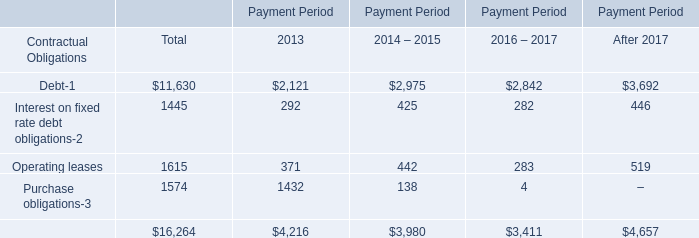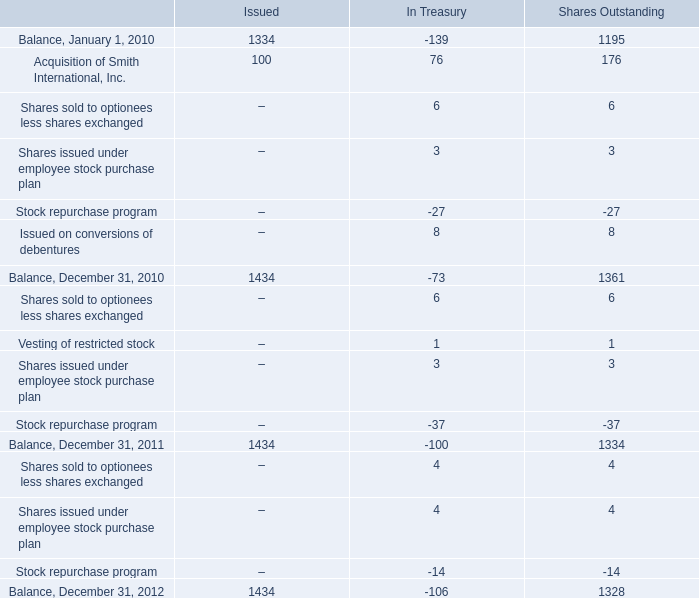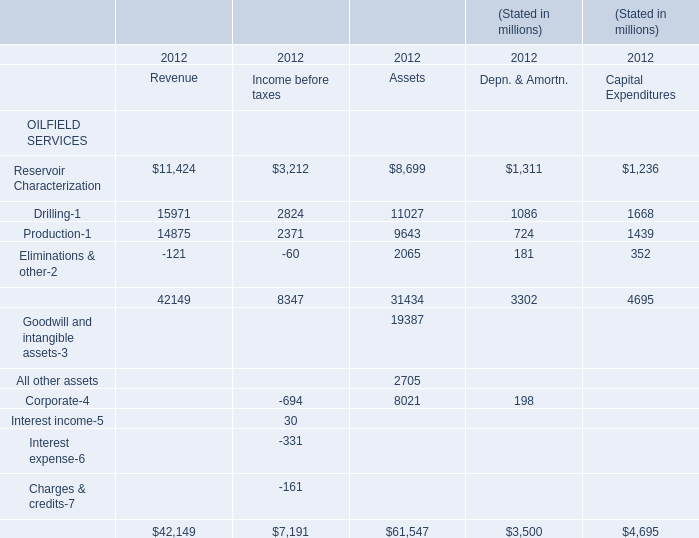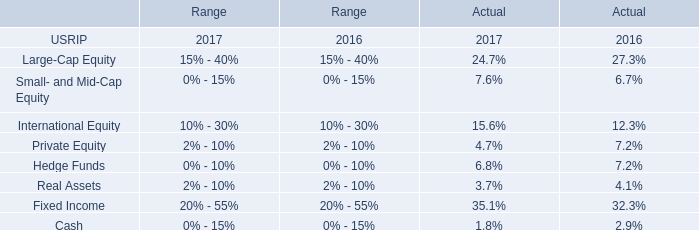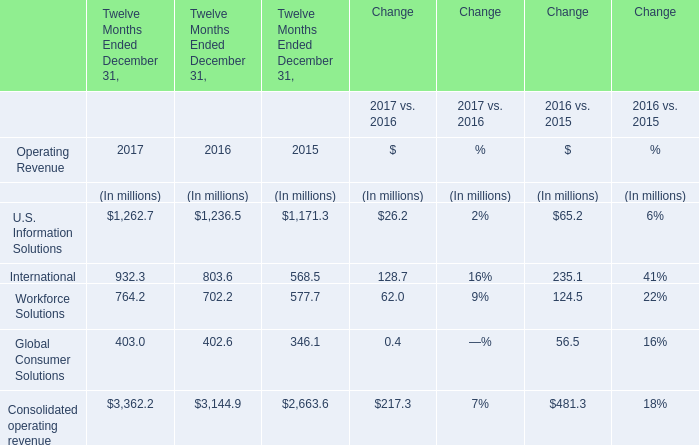What is the difference between Revenue Income before taxes 's highest Reservoir Characterization ?? (in million) 
Computations: (3212 - 11424)
Answer: -8212.0. 